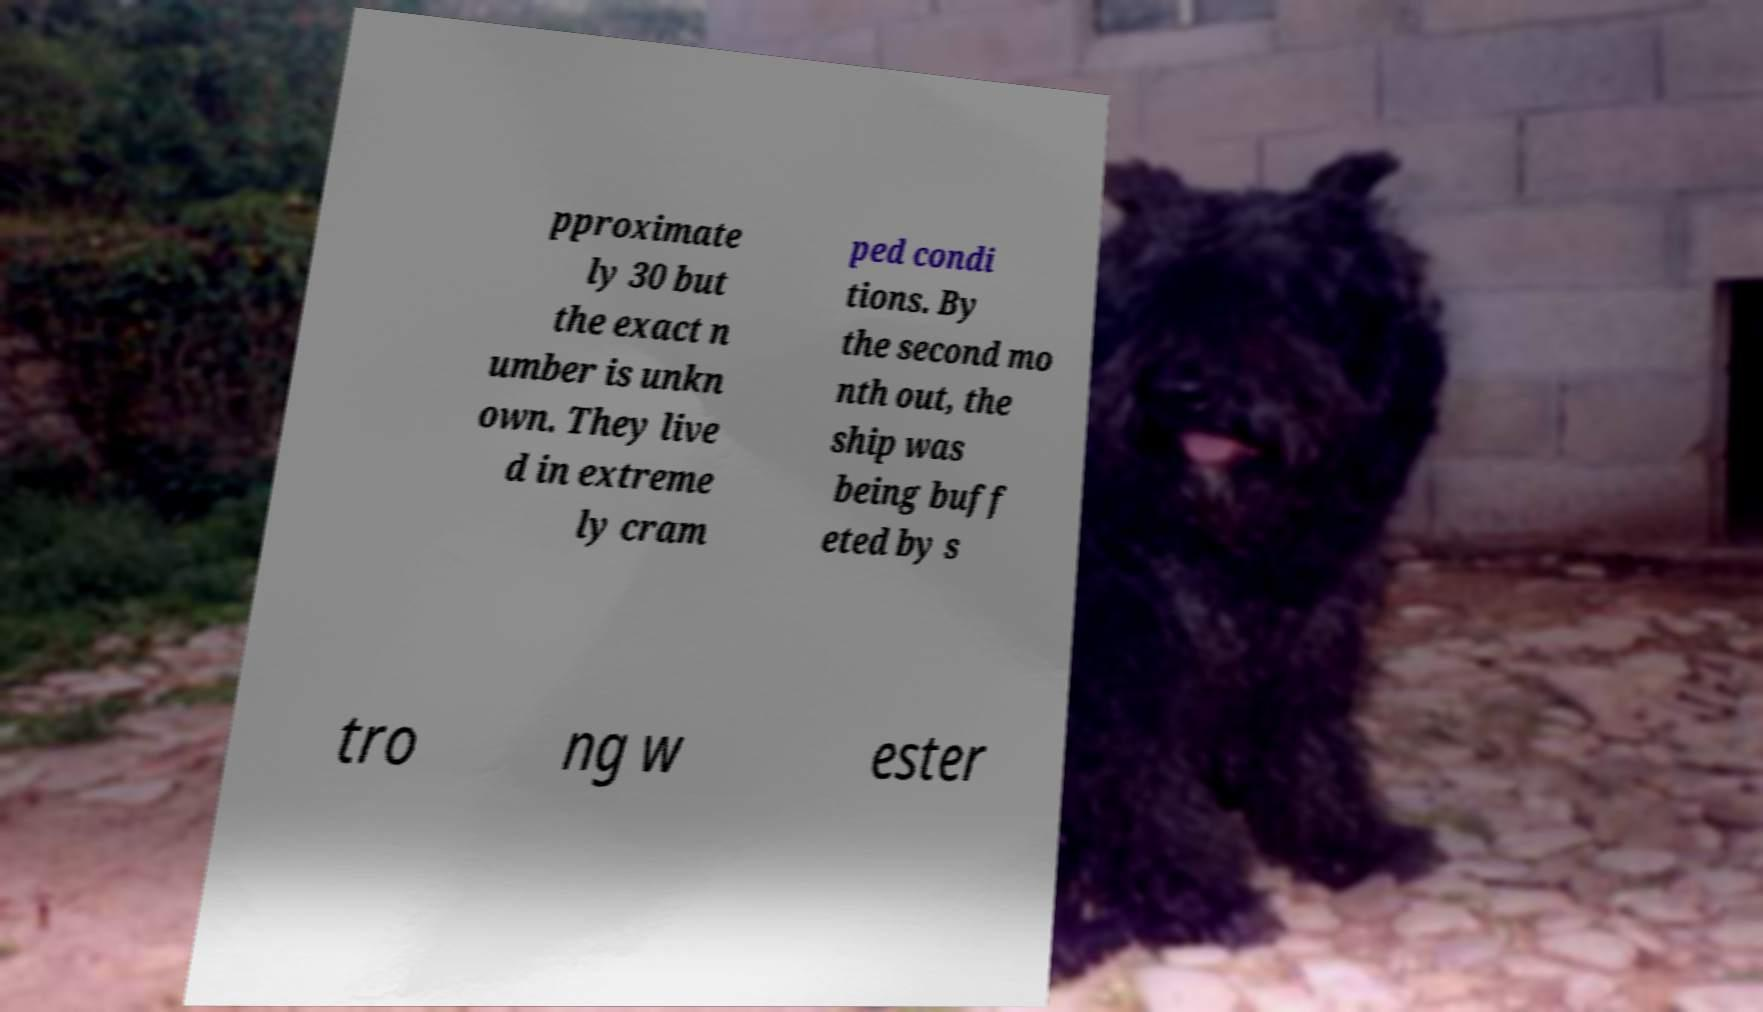There's text embedded in this image that I need extracted. Can you transcribe it verbatim? pproximate ly 30 but the exact n umber is unkn own. They live d in extreme ly cram ped condi tions. By the second mo nth out, the ship was being buff eted by s tro ng w ester 